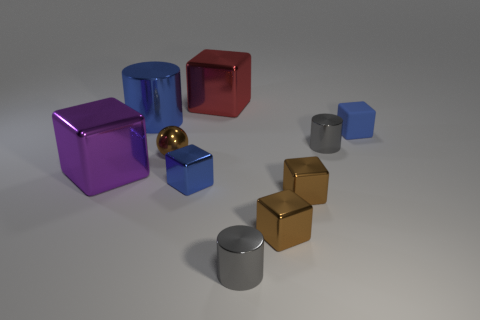Subtract all blue blocks. How many blocks are left? 4 Subtract all purple cubes. How many cubes are left? 5 Subtract all gray cubes. Subtract all cyan cylinders. How many cubes are left? 6 Subtract all balls. How many objects are left? 9 Add 6 big cyan metallic balls. How many big cyan metallic balls exist? 6 Subtract 0 purple spheres. How many objects are left? 10 Subtract all red metallic blocks. Subtract all small purple matte spheres. How many objects are left? 9 Add 6 small blue metallic things. How many small blue metallic things are left? 7 